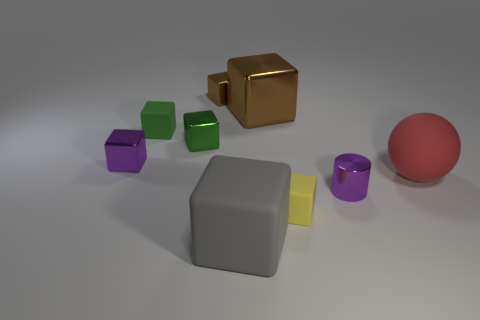How many green rubber cubes are there?
Your response must be concise. 1. How many red balls have the same material as the tiny yellow object?
Give a very brief answer. 1. How many objects are either blocks that are behind the large gray rubber thing or large blue shiny things?
Your answer should be compact. 6. Is the number of big red matte things that are to the left of the large ball less than the number of large brown blocks in front of the green rubber cube?
Offer a terse response. No. Are there any brown shiny things to the left of the gray object?
Provide a succinct answer. Yes. How many objects are purple shiny objects that are in front of the large red matte ball or purple objects in front of the red sphere?
Give a very brief answer. 1. What number of other rubber spheres are the same color as the large sphere?
Offer a terse response. 0. What color is the large metal object that is the same shape as the small green matte thing?
Keep it short and to the point. Brown. What shape is the metal object that is both on the right side of the gray matte block and behind the rubber sphere?
Offer a very short reply. Cube. Is the number of large gray matte cubes greater than the number of tiny purple rubber blocks?
Provide a succinct answer. Yes. 